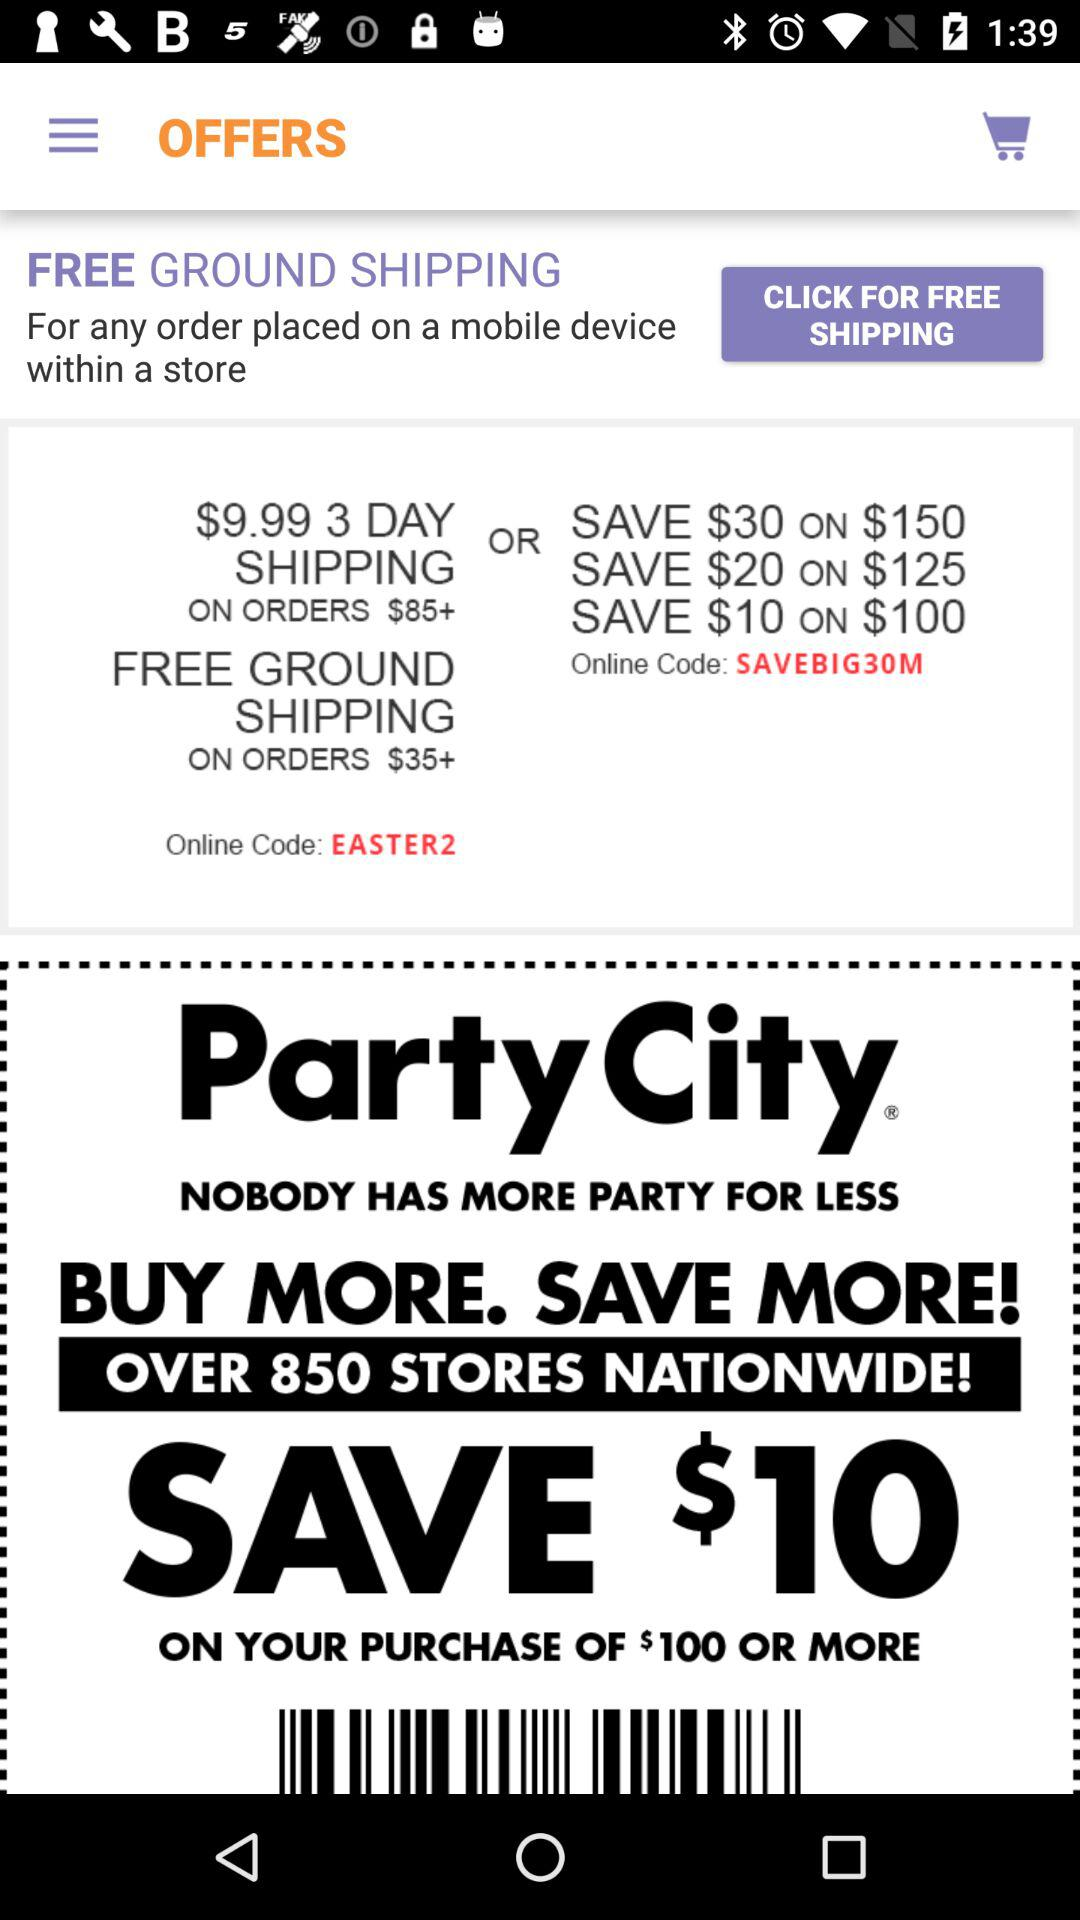What is the currency of price? The currency of price is the dollar. 